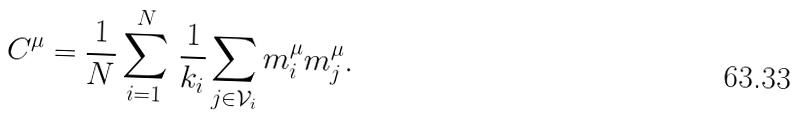Convert formula to latex. <formula><loc_0><loc_0><loc_500><loc_500>C ^ { \mu } = \frac { 1 } { N } \sum _ { i = 1 } ^ { N } { \, \frac { 1 } { k _ { i } } \sum _ { j \in { \mathcal { V } } _ { i } } { m ^ { \mu } _ { i } m ^ { \mu } _ { j } } } .</formula> 